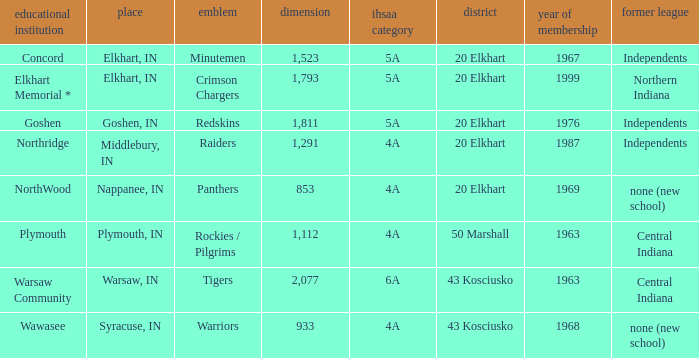What country joined before 1976, with IHSSA class of 5a, and a size larger than 1,112? 20 Elkhart. 